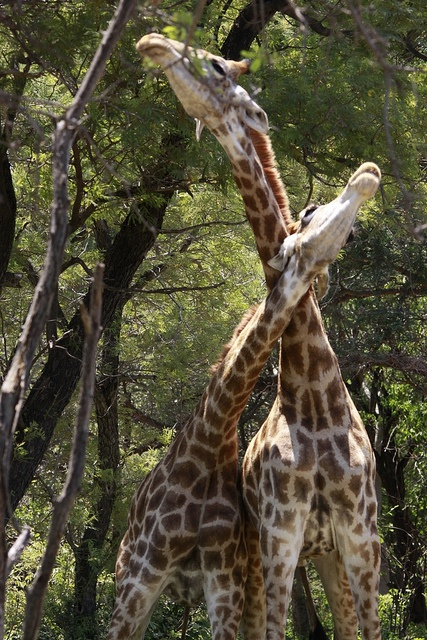Describe the objects in this image and their specific colors. I can see giraffe in black, gray, and maroon tones and giraffe in black and gray tones in this image. 